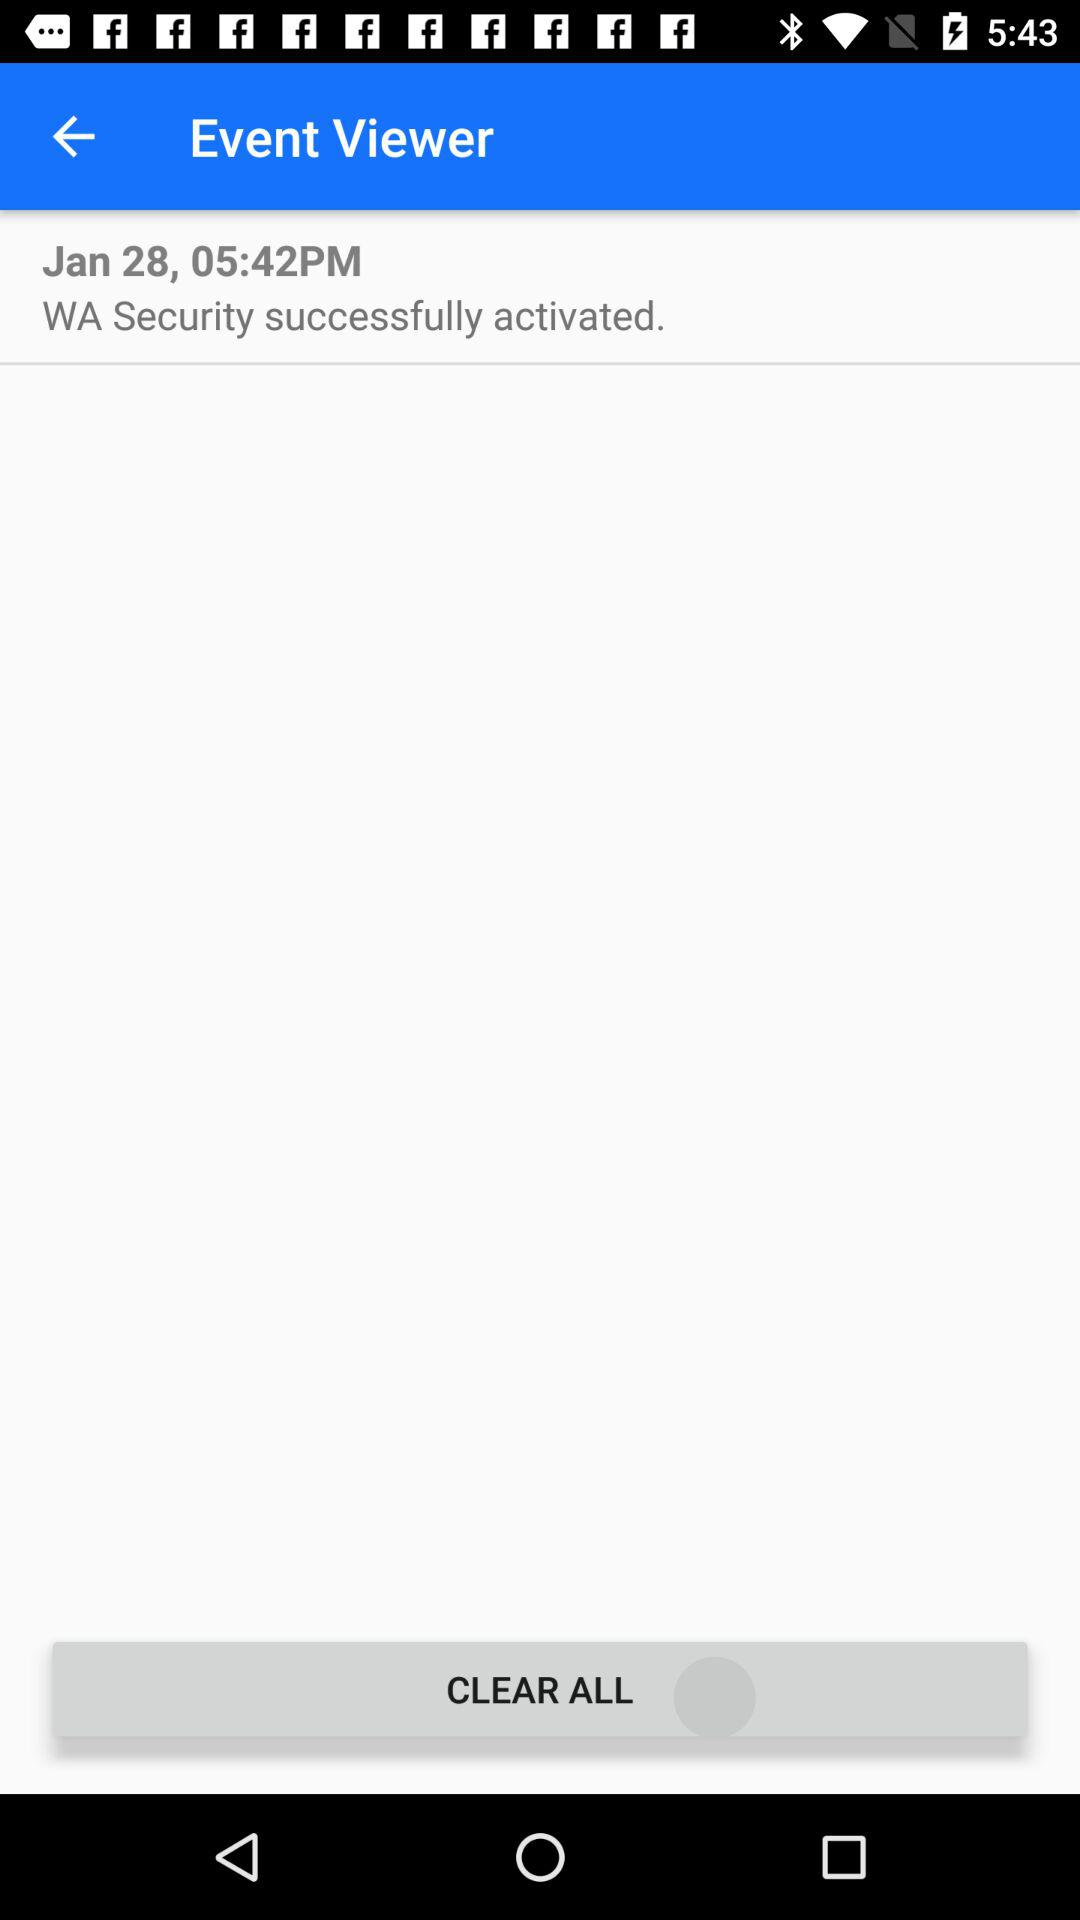What is the date? The date is January 28. 